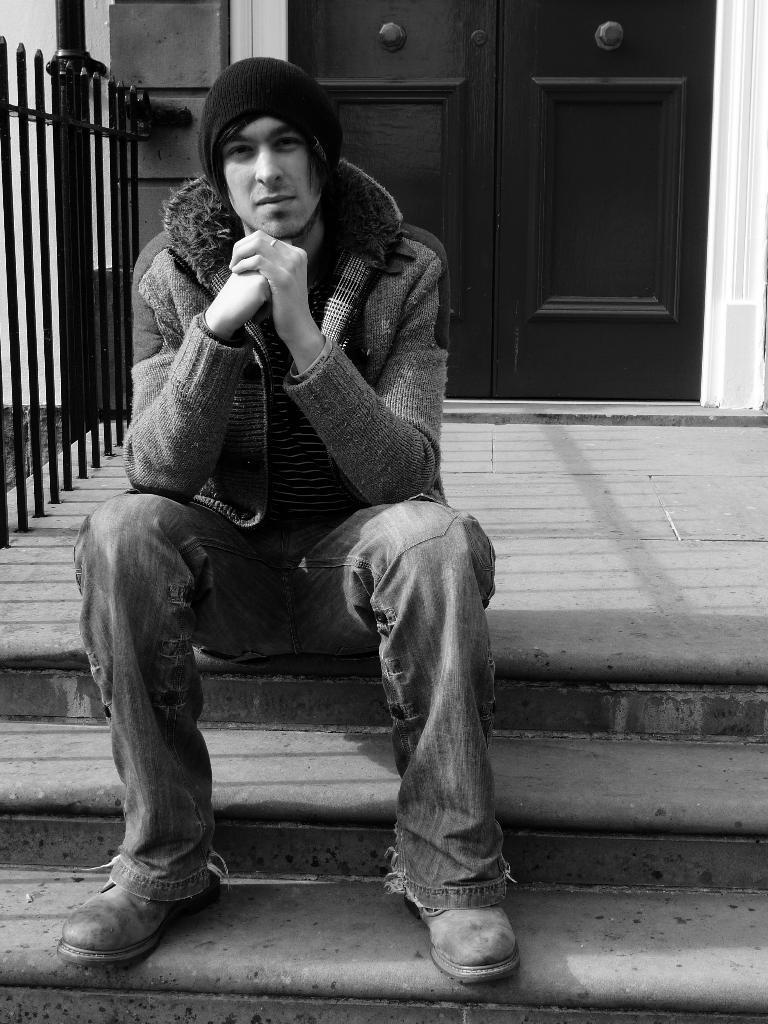What is the person in the image doing? The person is sitting on the stairs. What else can be seen in the image besides the person? There is a door visible in the image. What is the color scheme of the image? The image is in black and white color. Can you see any ghosts in the image? There are no ghosts present in the image. What town is the image taken in? The provided facts do not mention a town, so it cannot be determined from the image. 